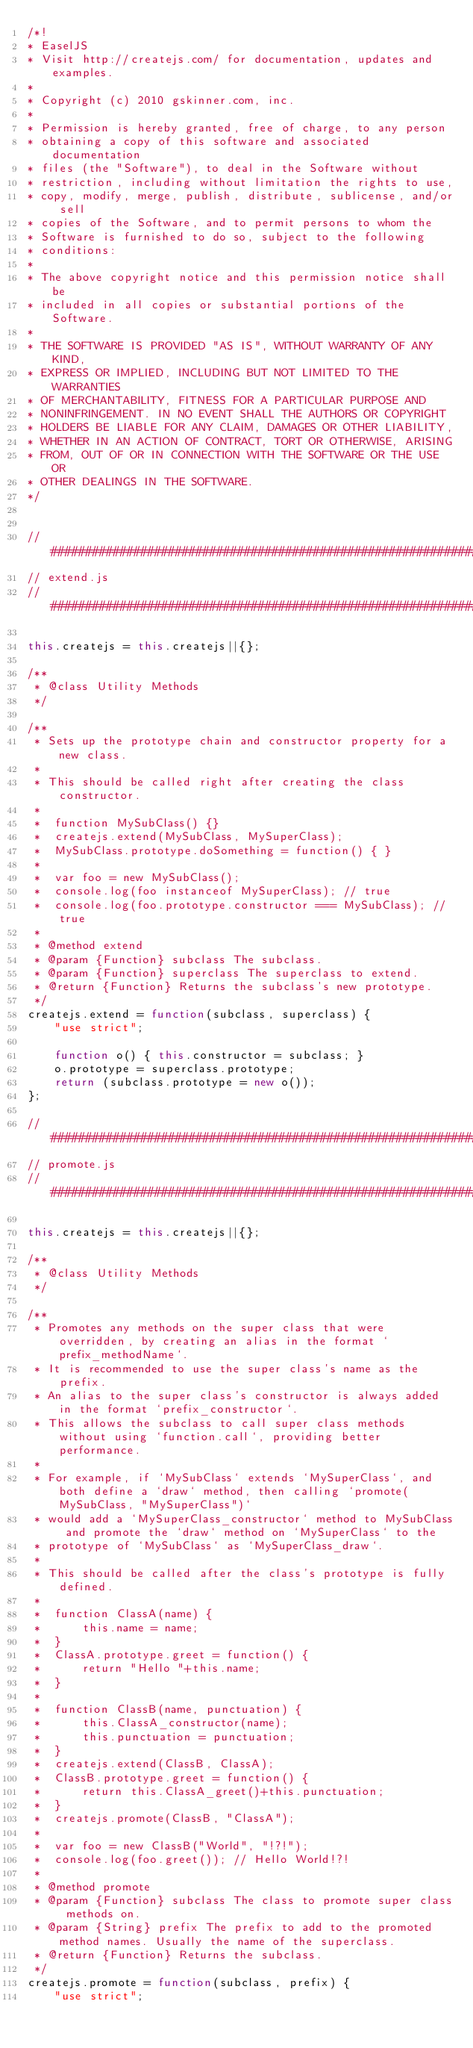<code> <loc_0><loc_0><loc_500><loc_500><_JavaScript_>/*!
* EaselJS
* Visit http://createjs.com/ for documentation, updates and examples.
*
* Copyright (c) 2010 gskinner.com, inc.
*
* Permission is hereby granted, free of charge, to any person
* obtaining a copy of this software and associated documentation
* files (the "Software"), to deal in the Software without
* restriction, including without limitation the rights to use,
* copy, modify, merge, publish, distribute, sublicense, and/or sell
* copies of the Software, and to permit persons to whom the
* Software is furnished to do so, subject to the following
* conditions:
*
* The above copyright notice and this permission notice shall be
* included in all copies or substantial portions of the Software.
*
* THE SOFTWARE IS PROVIDED "AS IS", WITHOUT WARRANTY OF ANY KIND,
* EXPRESS OR IMPLIED, INCLUDING BUT NOT LIMITED TO THE WARRANTIES
* OF MERCHANTABILITY, FITNESS FOR A PARTICULAR PURPOSE AND
* NONINFRINGEMENT. IN NO EVENT SHALL THE AUTHORS OR COPYRIGHT
* HOLDERS BE LIABLE FOR ANY CLAIM, DAMAGES OR OTHER LIABILITY,
* WHETHER IN AN ACTION OF CONTRACT, TORT OR OTHERWISE, ARISING
* FROM, OUT OF OR IN CONNECTION WITH THE SOFTWARE OR THE USE OR
* OTHER DEALINGS IN THE SOFTWARE.
*/


//##############################################################################
// extend.js
//##############################################################################

this.createjs = this.createjs||{};

/**
 * @class Utility Methods
 */

/**
 * Sets up the prototype chain and constructor property for a new class.
 *
 * This should be called right after creating the class constructor.
 *
 * 	function MySubClass() {}
 * 	createjs.extend(MySubClass, MySuperClass);
 * 	MySubClass.prototype.doSomething = function() { }
 *
 * 	var foo = new MySubClass();
 * 	console.log(foo instanceof MySuperClass); // true
 * 	console.log(foo.prototype.constructor === MySubClass); // true
 *
 * @method extend
 * @param {Function} subclass The subclass.
 * @param {Function} superclass The superclass to extend.
 * @return {Function} Returns the subclass's new prototype.
 */
createjs.extend = function(subclass, superclass) {
	"use strict";

	function o() { this.constructor = subclass; }
	o.prototype = superclass.prototype;
	return (subclass.prototype = new o());
};

//##############################################################################
// promote.js
//##############################################################################

this.createjs = this.createjs||{};

/**
 * @class Utility Methods
 */

/**
 * Promotes any methods on the super class that were overridden, by creating an alias in the format `prefix_methodName`.
 * It is recommended to use the super class's name as the prefix.
 * An alias to the super class's constructor is always added in the format `prefix_constructor`.
 * This allows the subclass to call super class methods without using `function.call`, providing better performance.
 *
 * For example, if `MySubClass` extends `MySuperClass`, and both define a `draw` method, then calling `promote(MySubClass, "MySuperClass")`
 * would add a `MySuperClass_constructor` method to MySubClass and promote the `draw` method on `MySuperClass` to the
 * prototype of `MySubClass` as `MySuperClass_draw`.
 *
 * This should be called after the class's prototype is fully defined.
 *
 * 	function ClassA(name) {
 * 		this.name = name;
 * 	}
 * 	ClassA.prototype.greet = function() {
 * 		return "Hello "+this.name;
 * 	}
 *
 * 	function ClassB(name, punctuation) {
 * 		this.ClassA_constructor(name);
 * 		this.punctuation = punctuation;
 * 	}
 * 	createjs.extend(ClassB, ClassA);
 * 	ClassB.prototype.greet = function() {
 * 		return this.ClassA_greet()+this.punctuation;
 * 	}
 * 	createjs.promote(ClassB, "ClassA");
 *
 * 	var foo = new ClassB("World", "!?!");
 * 	console.log(foo.greet()); // Hello World!?!
 *
 * @method promote
 * @param {Function} subclass The class to promote super class methods on.
 * @param {String} prefix The prefix to add to the promoted method names. Usually the name of the superclass.
 * @return {Function} Returns the subclass.
 */
createjs.promote = function(subclass, prefix) {
	"use strict";
</code> 